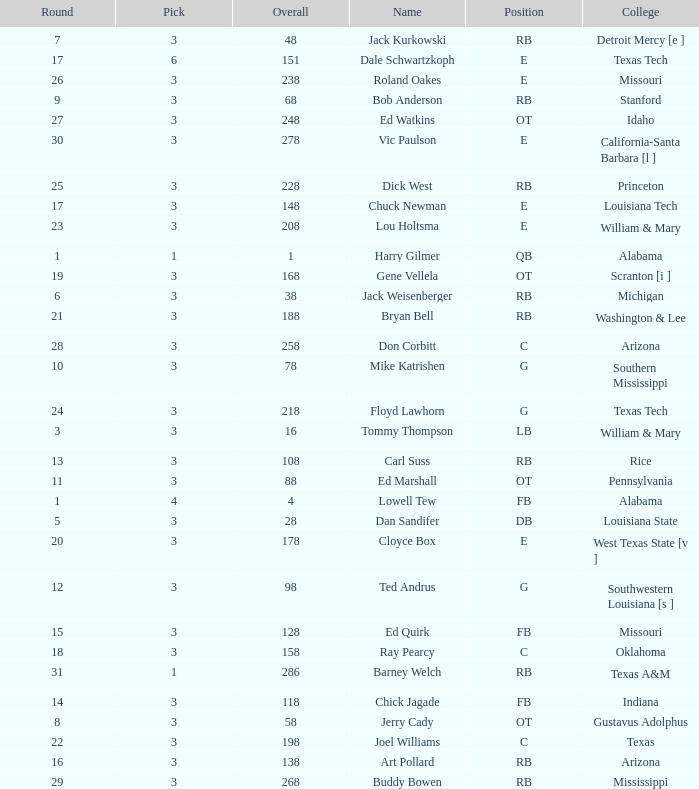How much Overall has a Name of bob anderson? 1.0. 